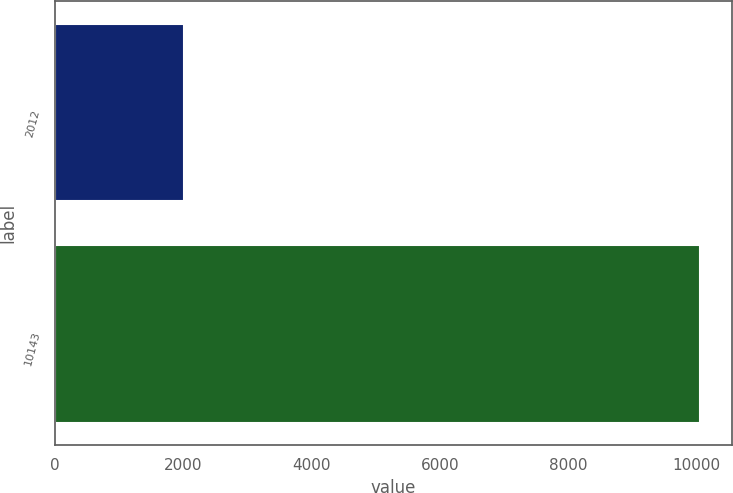Convert chart. <chart><loc_0><loc_0><loc_500><loc_500><bar_chart><fcel>2012<fcel>10143<nl><fcel>2011<fcel>10050<nl></chart> 